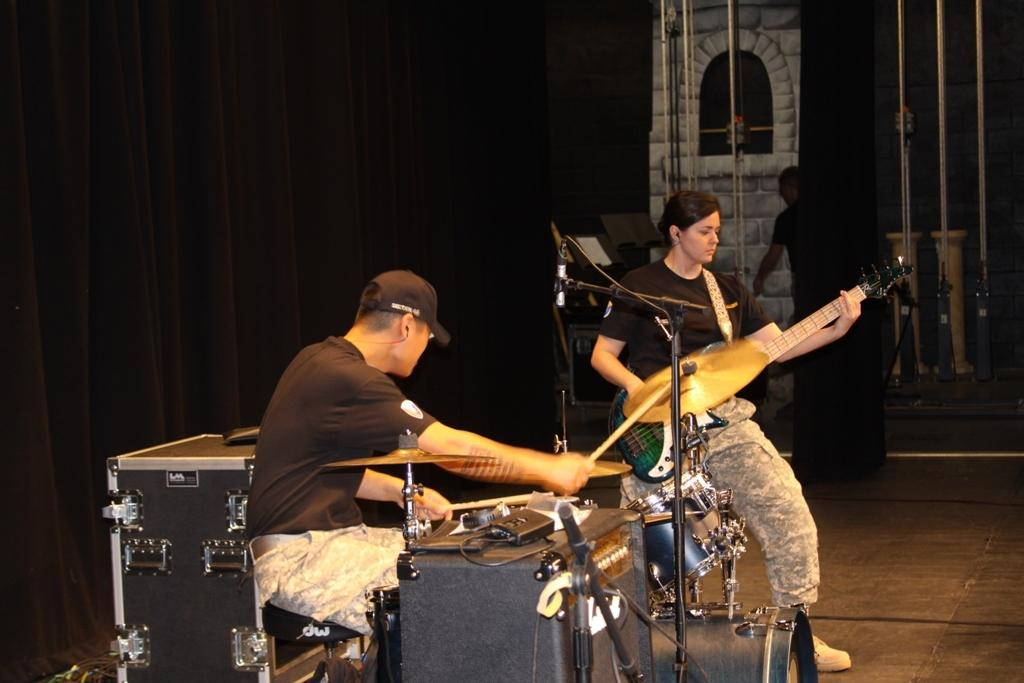What are the two people in the image doing? The two people in the image are playing musical instruments. What are the people wearing? Both people are wearing black t-shirts. Can you describe any additional clothing or accessories? One person is wearing a cap. What can be seen in the background of the image? There is a curtain visible in the background of the image. What type of laborer is working in the church depicted in the image? There is no church or laborer present in the image; it features two people playing musical instruments. How many times has the person in the cap folded the curtain in the image? There is no indication in the image that the person in the cap has interacted with the curtain, so it cannot be determined. 